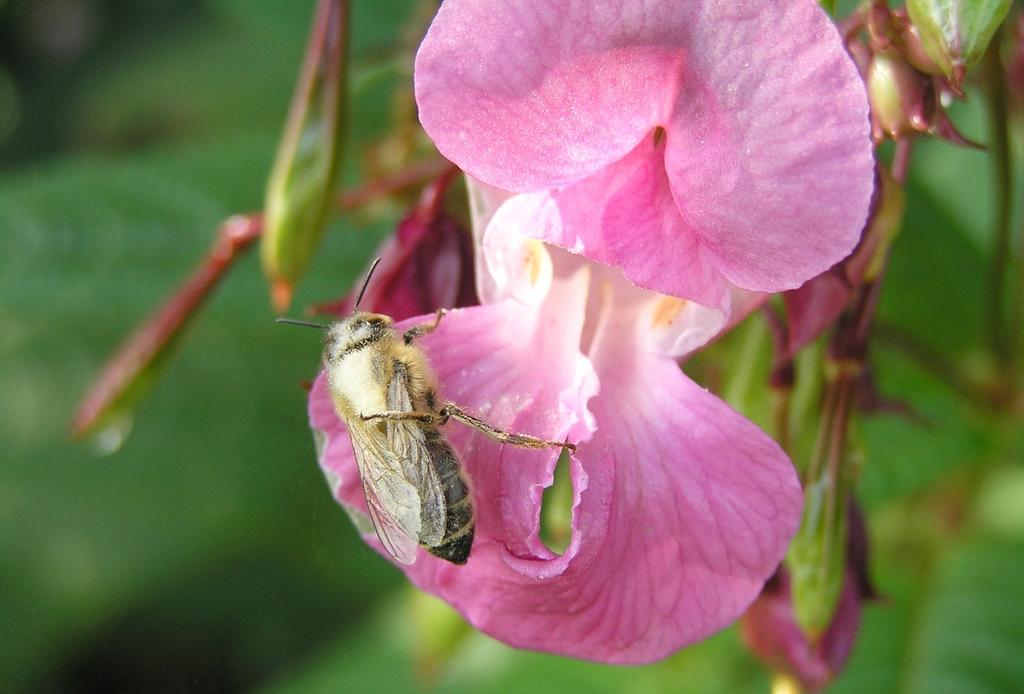What is the main subject of the image? There is a bee in the image. Where is the bee located? The bee is on a flower. Can you describe the background of the image? The background of the image is blurred. How many babies are participating in the event depicted in the image? There are no babies or events depicted in the image; it features a bee on a flower with a blurred background. 